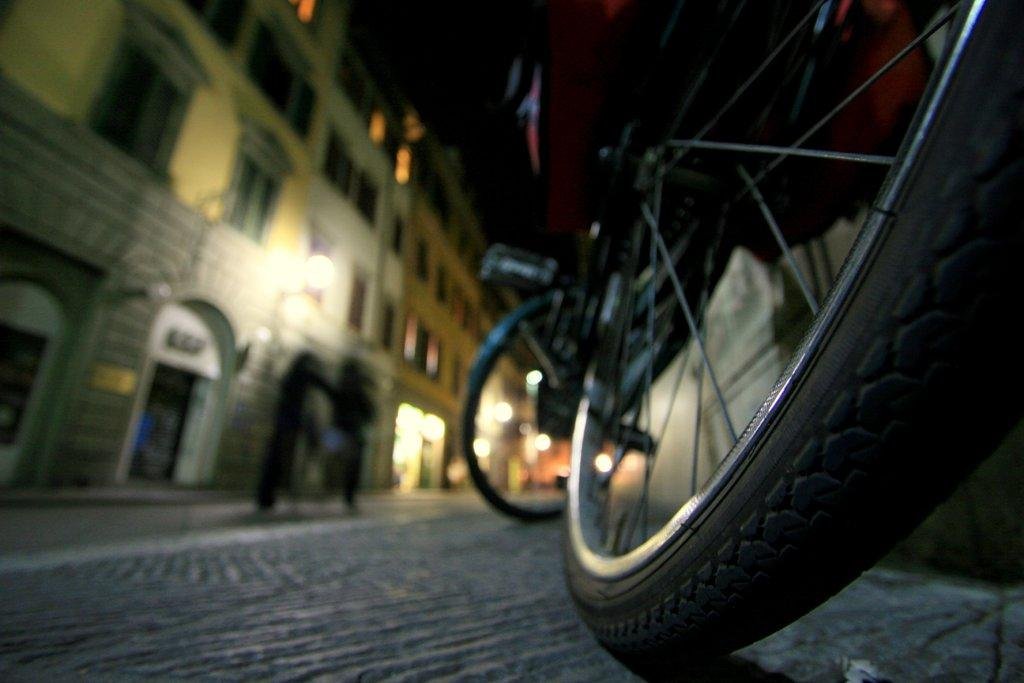What can be seen on the right side of the image? There is a bicycle on the right side of the image. What is visible in the background of the image? There are buildings in the background of the image. What is in the center of the image? There is a road in the center of the image. How many people are present on the road? Two persons are present on the road. Can you see any teeth or a kitten playing near the sea in the image? There is no sea, tooth, or kitten present in the image. 